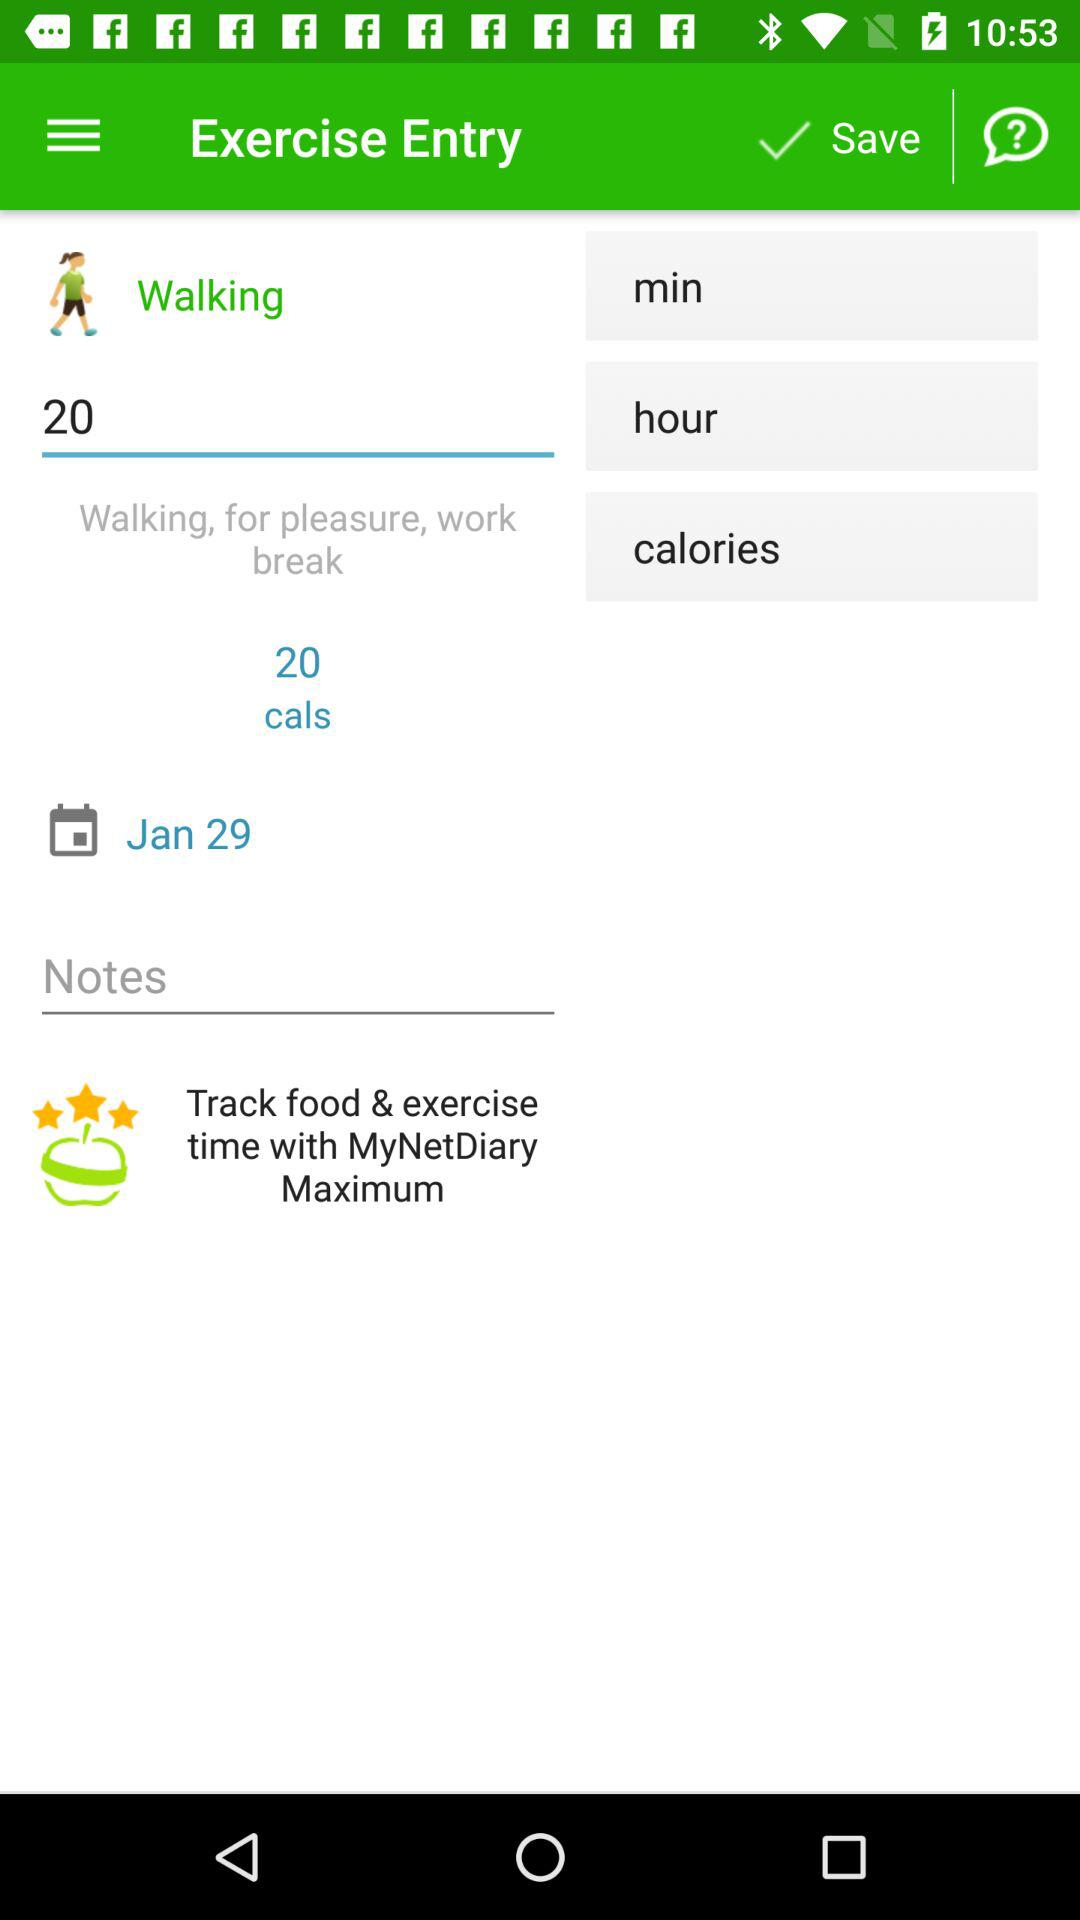How many calories are being burned?
Answer the question using a single word or phrase. 20 cals 